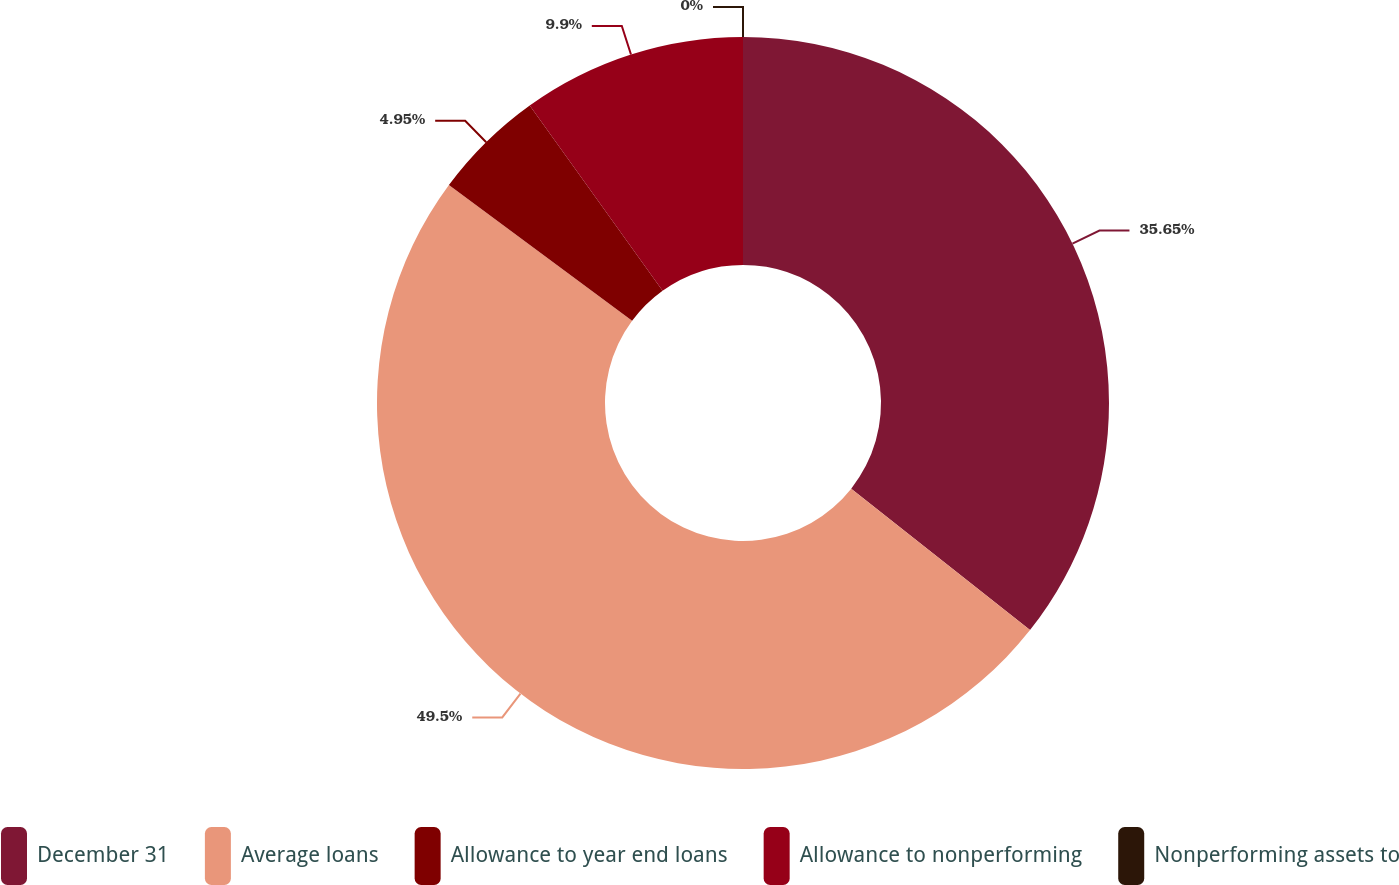<chart> <loc_0><loc_0><loc_500><loc_500><pie_chart><fcel>December 31<fcel>Average loans<fcel>Allowance to year end loans<fcel>Allowance to nonperforming<fcel>Nonperforming assets to<nl><fcel>35.65%<fcel>49.49%<fcel>4.95%<fcel>9.9%<fcel>0.0%<nl></chart> 